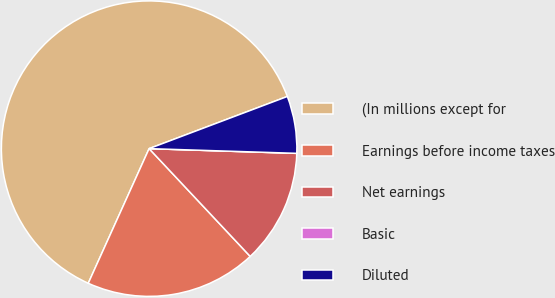<chart> <loc_0><loc_0><loc_500><loc_500><pie_chart><fcel>(In millions except for<fcel>Earnings before income taxes<fcel>Net earnings<fcel>Basic<fcel>Diluted<nl><fcel>62.5%<fcel>18.75%<fcel>12.5%<fcel>0.0%<fcel>6.25%<nl></chart> 